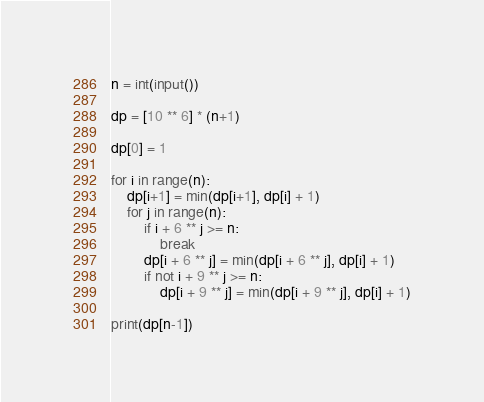Convert code to text. <code><loc_0><loc_0><loc_500><loc_500><_Python_>n = int(input())

dp = [10 ** 6] * (n+1)

dp[0] = 1

for i in range(n):
    dp[i+1] = min(dp[i+1], dp[i] + 1)
    for j in range(n):
        if i + 6 ** j >= n:
            break
        dp[i + 6 ** j] = min(dp[i + 6 ** j], dp[i] + 1)
        if not i + 9 ** j >= n:
            dp[i + 9 ** j] = min(dp[i + 9 ** j], dp[i] + 1)

print(dp[n-1])
</code> 